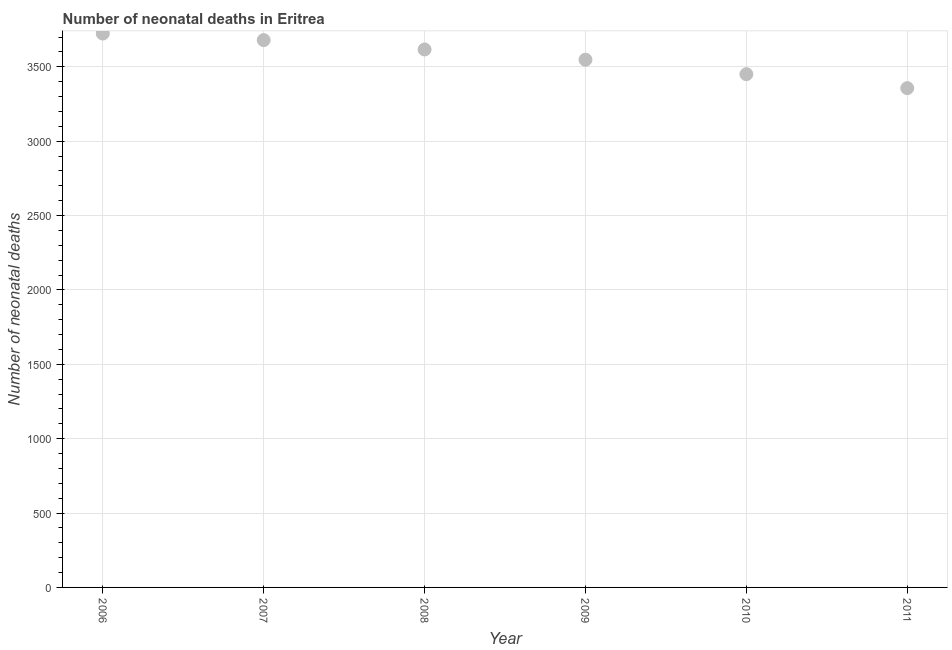What is the number of neonatal deaths in 2009?
Offer a terse response. 3548. Across all years, what is the maximum number of neonatal deaths?
Your response must be concise. 3724. Across all years, what is the minimum number of neonatal deaths?
Ensure brevity in your answer.  3357. What is the sum of the number of neonatal deaths?
Your answer should be very brief. 2.14e+04. What is the difference between the number of neonatal deaths in 2006 and 2007?
Your response must be concise. 44. What is the average number of neonatal deaths per year?
Provide a succinct answer. 3562.83. What is the median number of neonatal deaths?
Ensure brevity in your answer.  3582.5. In how many years, is the number of neonatal deaths greater than 2700 ?
Your response must be concise. 6. What is the ratio of the number of neonatal deaths in 2006 to that in 2011?
Your answer should be very brief. 1.11. Is the difference between the number of neonatal deaths in 2006 and 2007 greater than the difference between any two years?
Offer a very short reply. No. What is the difference between the highest and the lowest number of neonatal deaths?
Provide a succinct answer. 367. Does the number of neonatal deaths monotonically increase over the years?
Offer a terse response. No. How many dotlines are there?
Give a very brief answer. 1. Does the graph contain any zero values?
Offer a very short reply. No. Does the graph contain grids?
Make the answer very short. Yes. What is the title of the graph?
Make the answer very short. Number of neonatal deaths in Eritrea. What is the label or title of the X-axis?
Give a very brief answer. Year. What is the label or title of the Y-axis?
Give a very brief answer. Number of neonatal deaths. What is the Number of neonatal deaths in 2006?
Give a very brief answer. 3724. What is the Number of neonatal deaths in 2007?
Make the answer very short. 3680. What is the Number of neonatal deaths in 2008?
Make the answer very short. 3617. What is the Number of neonatal deaths in 2009?
Provide a short and direct response. 3548. What is the Number of neonatal deaths in 2010?
Your answer should be very brief. 3451. What is the Number of neonatal deaths in 2011?
Keep it short and to the point. 3357. What is the difference between the Number of neonatal deaths in 2006 and 2007?
Provide a succinct answer. 44. What is the difference between the Number of neonatal deaths in 2006 and 2008?
Your response must be concise. 107. What is the difference between the Number of neonatal deaths in 2006 and 2009?
Your answer should be very brief. 176. What is the difference between the Number of neonatal deaths in 2006 and 2010?
Provide a succinct answer. 273. What is the difference between the Number of neonatal deaths in 2006 and 2011?
Offer a very short reply. 367. What is the difference between the Number of neonatal deaths in 2007 and 2009?
Provide a succinct answer. 132. What is the difference between the Number of neonatal deaths in 2007 and 2010?
Offer a terse response. 229. What is the difference between the Number of neonatal deaths in 2007 and 2011?
Your answer should be very brief. 323. What is the difference between the Number of neonatal deaths in 2008 and 2010?
Provide a short and direct response. 166. What is the difference between the Number of neonatal deaths in 2008 and 2011?
Your answer should be compact. 260. What is the difference between the Number of neonatal deaths in 2009 and 2010?
Your response must be concise. 97. What is the difference between the Number of neonatal deaths in 2009 and 2011?
Provide a succinct answer. 191. What is the difference between the Number of neonatal deaths in 2010 and 2011?
Make the answer very short. 94. What is the ratio of the Number of neonatal deaths in 2006 to that in 2008?
Offer a terse response. 1.03. What is the ratio of the Number of neonatal deaths in 2006 to that in 2010?
Offer a very short reply. 1.08. What is the ratio of the Number of neonatal deaths in 2006 to that in 2011?
Offer a very short reply. 1.11. What is the ratio of the Number of neonatal deaths in 2007 to that in 2008?
Offer a terse response. 1.02. What is the ratio of the Number of neonatal deaths in 2007 to that in 2009?
Keep it short and to the point. 1.04. What is the ratio of the Number of neonatal deaths in 2007 to that in 2010?
Ensure brevity in your answer.  1.07. What is the ratio of the Number of neonatal deaths in 2007 to that in 2011?
Offer a very short reply. 1.1. What is the ratio of the Number of neonatal deaths in 2008 to that in 2010?
Your answer should be very brief. 1.05. What is the ratio of the Number of neonatal deaths in 2008 to that in 2011?
Your answer should be very brief. 1.08. What is the ratio of the Number of neonatal deaths in 2009 to that in 2010?
Your response must be concise. 1.03. What is the ratio of the Number of neonatal deaths in 2009 to that in 2011?
Offer a terse response. 1.06. What is the ratio of the Number of neonatal deaths in 2010 to that in 2011?
Provide a short and direct response. 1.03. 